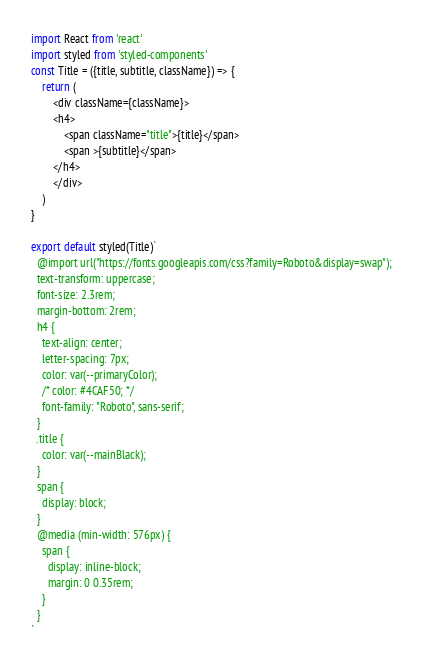<code> <loc_0><loc_0><loc_500><loc_500><_JavaScript_>import React from 'react'
import styled from 'styled-components'
const Title = ({title, subtitle, className}) => {
    return (
        <div className={className}>
        <h4>
            <span className="title">{title}</span>
            <span >{subtitle}</span>
        </h4>
        </div>
    )
}

export default styled(Title)`
  @import url("https://fonts.googleapis.com/css?family=Roboto&display=swap");
  text-transform: uppercase;
  font-size: 2.3rem;
  margin-bottom: 2rem;
  h4 {
    text-align: center;
    letter-spacing: 7px;
    color: var(--primaryColor);
    /* color: #4CAF50; */
    font-family: "Roboto", sans-serif;
  }
  .title {
    color: var(--mainBlack);   
  }
  span {
    display: block;
  }
  @media (min-width: 576px) {
    span {
      display: inline-block;
      margin: 0 0.35rem;
    }
  }
`

</code> 